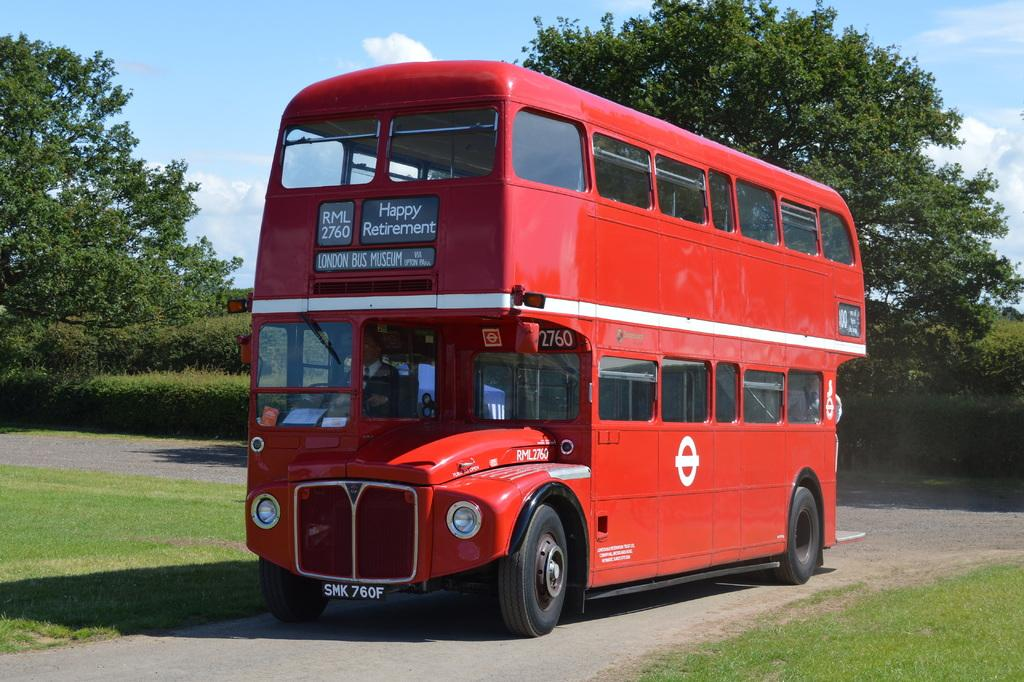<image>
Offer a succinct explanation of the picture presented. A red double decker bus with Happy Retirement written on it 